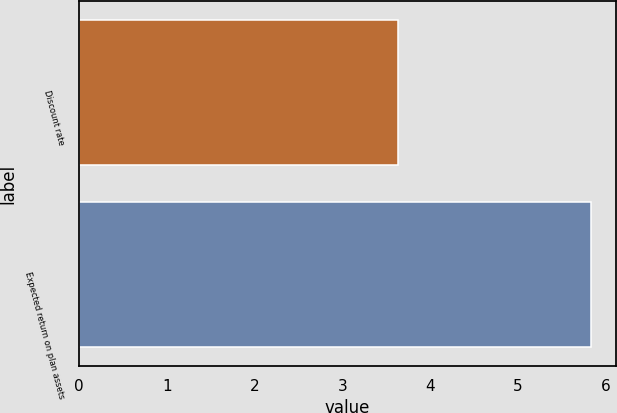<chart> <loc_0><loc_0><loc_500><loc_500><bar_chart><fcel>Discount rate<fcel>Expected return on plan assets<nl><fcel>3.64<fcel>5.83<nl></chart> 